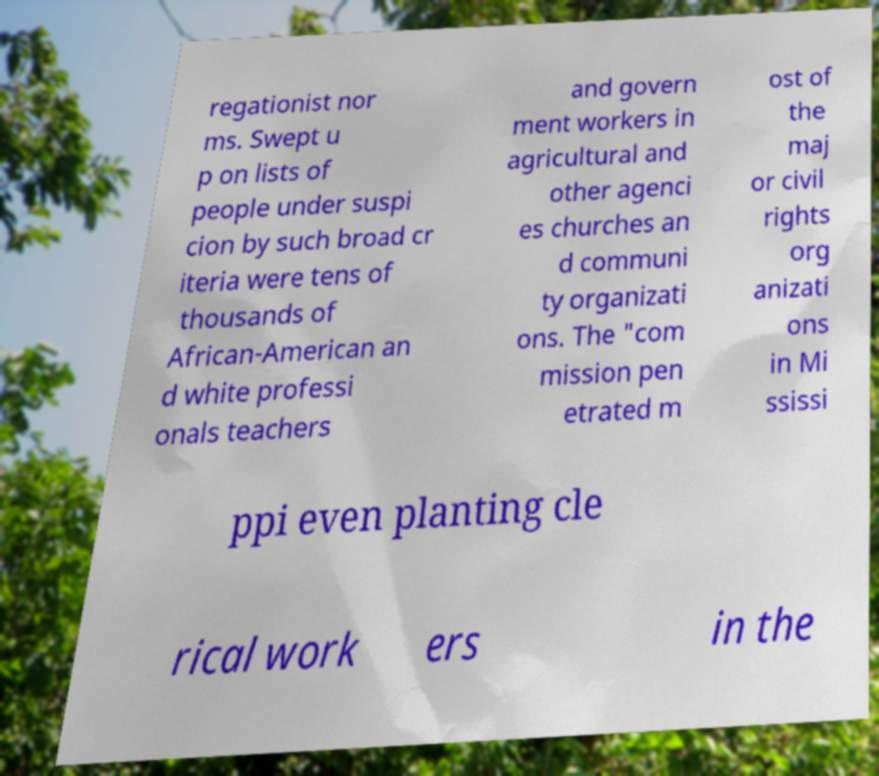Could you assist in decoding the text presented in this image and type it out clearly? regationist nor ms. Swept u p on lists of people under suspi cion by such broad cr iteria were tens of thousands of African-American an d white professi onals teachers and govern ment workers in agricultural and other agenci es churches an d communi ty organizati ons. The "com mission pen etrated m ost of the maj or civil rights org anizati ons in Mi ssissi ppi even planting cle rical work ers in the 